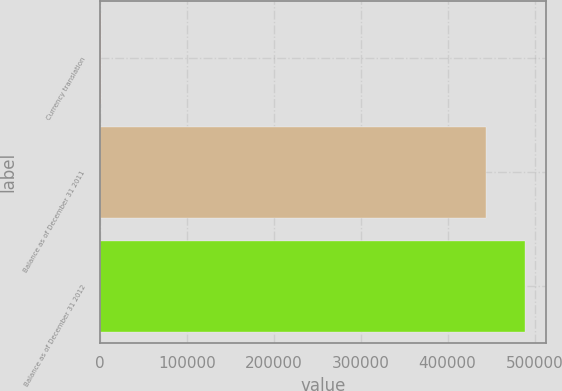<chart> <loc_0><loc_0><loc_500><loc_500><bar_chart><fcel>Currency translation<fcel>Balance as of December 31 2011<fcel>Balance as of December 31 2012<nl><fcel>1534<fcel>444431<fcel>489034<nl></chart> 